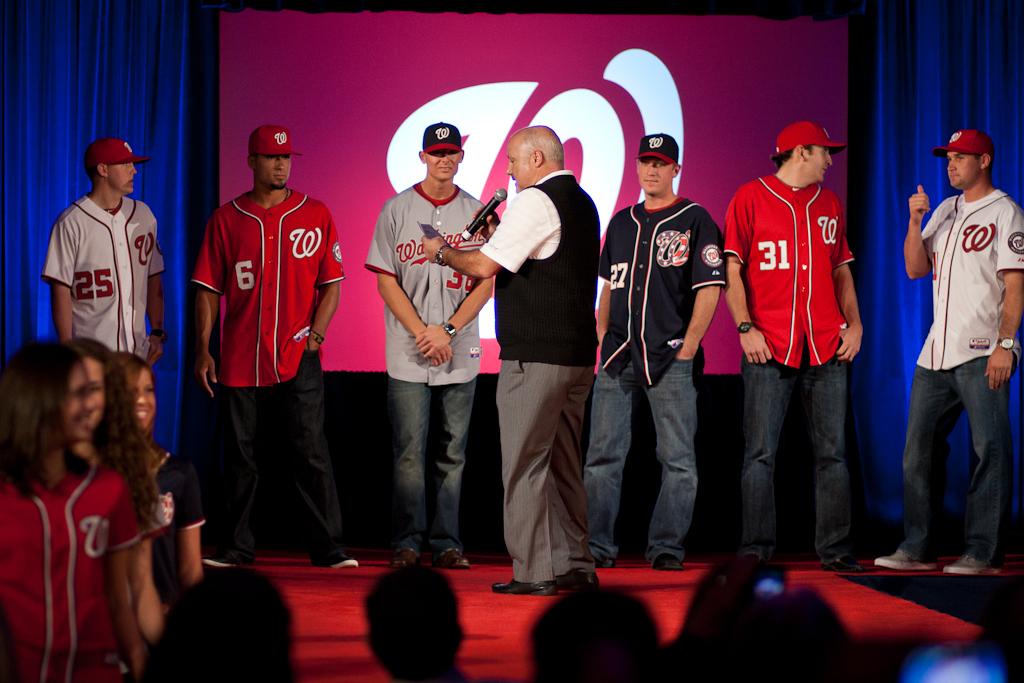What is the number of the red jersey on the right?
Keep it short and to the point. 31. 